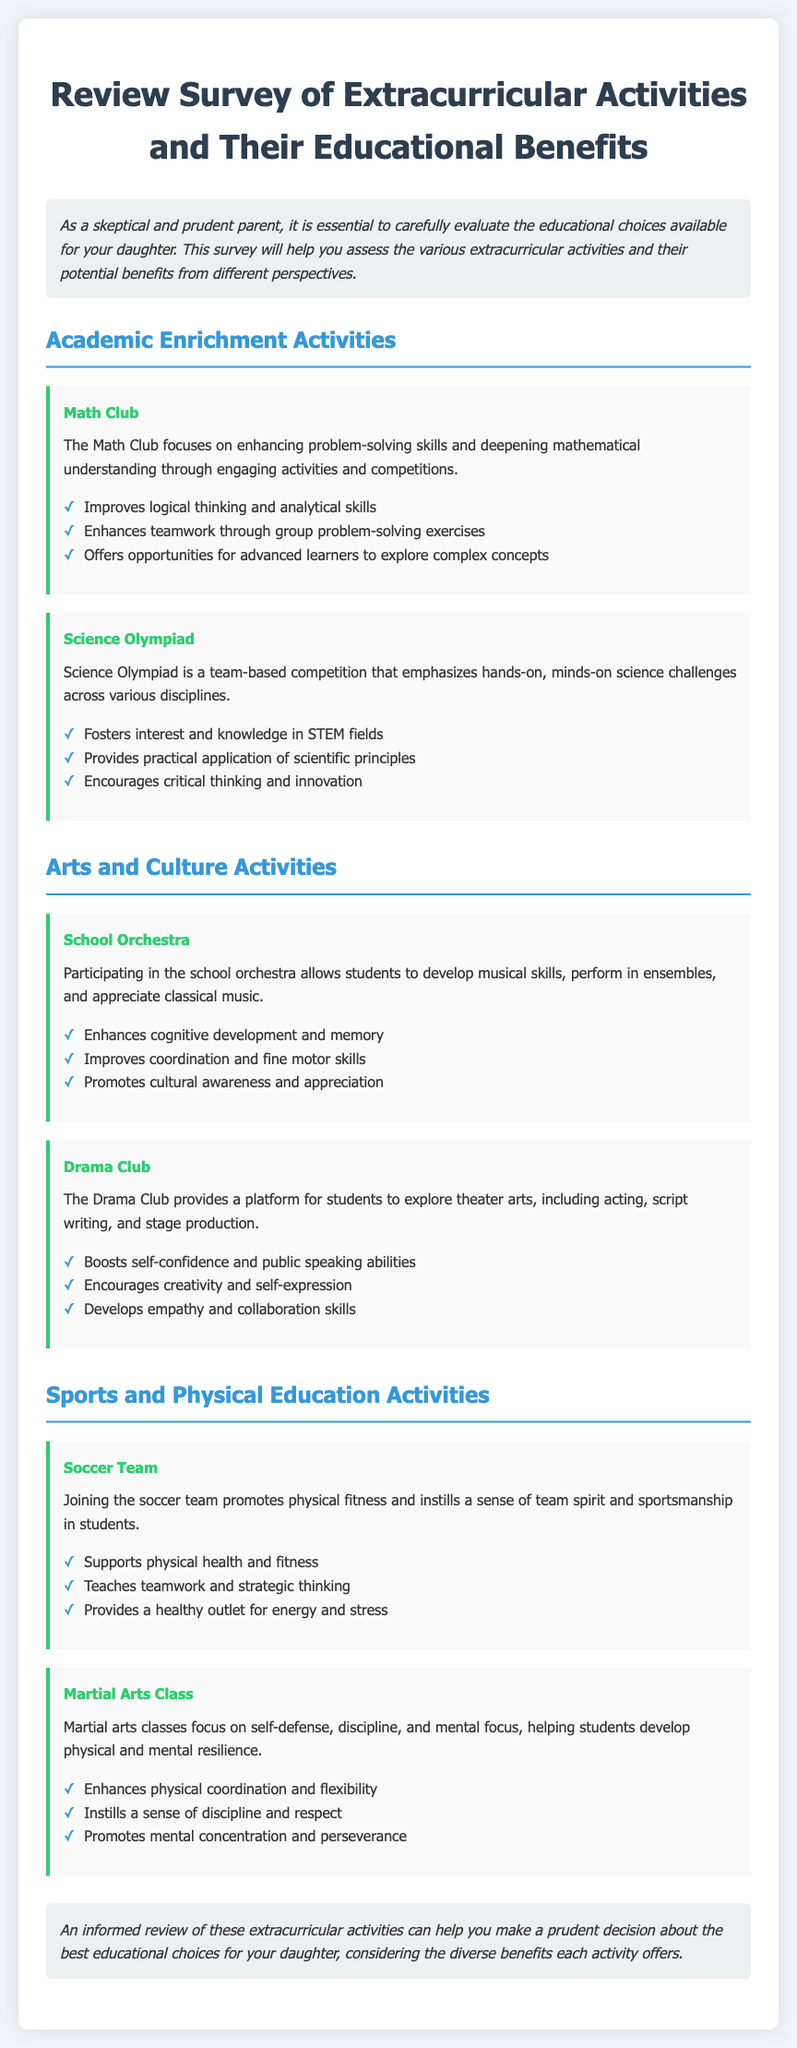what is the title of the document? The title is prominently displayed at the top of the document in a header format.
Answer: Review Survey of Extracurricular Activities and Their Educational Benefits what is one benefit of joining the Math Club? The benefits are listed in bullet points under the Math Club section.
Answer: Improves logical thinking and analytical skills how many activities are listed under the Arts and Culture Activities section? By counting the activities listed in the Arts and Culture section, we find the total.
Answer: 2 what is included in the activity description for the Science Olympiad? This description gives context about the focus and format of the activity.
Answer: team-based competition that emphasizes hands-on, minds-on science challenges which extracurricular activity promotes mental concentration and perseverance? This activity is noted for helping students develop specific mental qualities.
Answer: Martial Arts Class list one benefit of participating in the School Orchestra. The benefits are outlined in a list format for the School Orchestra.
Answer: Enhances cognitive development and memory which two types of activities are referenced in the Sports and Physical Education Activities section? This inquiry seeks to identify the specific activities mentioned in that section.
Answer: Soccer Team and Martial Arts Class what overarching theme does the conclusion suggest regarding extracurricular activities? The conclusion summarizes the purpose of the document regarding the activities.
Answer: make a prudent decision 